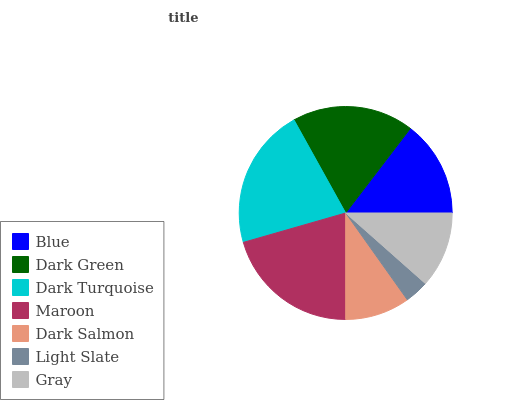Is Light Slate the minimum?
Answer yes or no. Yes. Is Dark Turquoise the maximum?
Answer yes or no. Yes. Is Dark Green the minimum?
Answer yes or no. No. Is Dark Green the maximum?
Answer yes or no. No. Is Dark Green greater than Blue?
Answer yes or no. Yes. Is Blue less than Dark Green?
Answer yes or no. Yes. Is Blue greater than Dark Green?
Answer yes or no. No. Is Dark Green less than Blue?
Answer yes or no. No. Is Blue the high median?
Answer yes or no. Yes. Is Blue the low median?
Answer yes or no. Yes. Is Maroon the high median?
Answer yes or no. No. Is Dark Turquoise the low median?
Answer yes or no. No. 